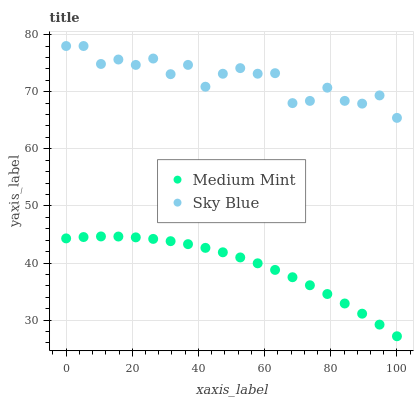Does Medium Mint have the minimum area under the curve?
Answer yes or no. Yes. Does Sky Blue have the maximum area under the curve?
Answer yes or no. Yes. Does Sky Blue have the minimum area under the curve?
Answer yes or no. No. Is Medium Mint the smoothest?
Answer yes or no. Yes. Is Sky Blue the roughest?
Answer yes or no. Yes. Is Sky Blue the smoothest?
Answer yes or no. No. Does Medium Mint have the lowest value?
Answer yes or no. Yes. Does Sky Blue have the lowest value?
Answer yes or no. No. Does Sky Blue have the highest value?
Answer yes or no. Yes. Is Medium Mint less than Sky Blue?
Answer yes or no. Yes. Is Sky Blue greater than Medium Mint?
Answer yes or no. Yes. Does Medium Mint intersect Sky Blue?
Answer yes or no. No. 